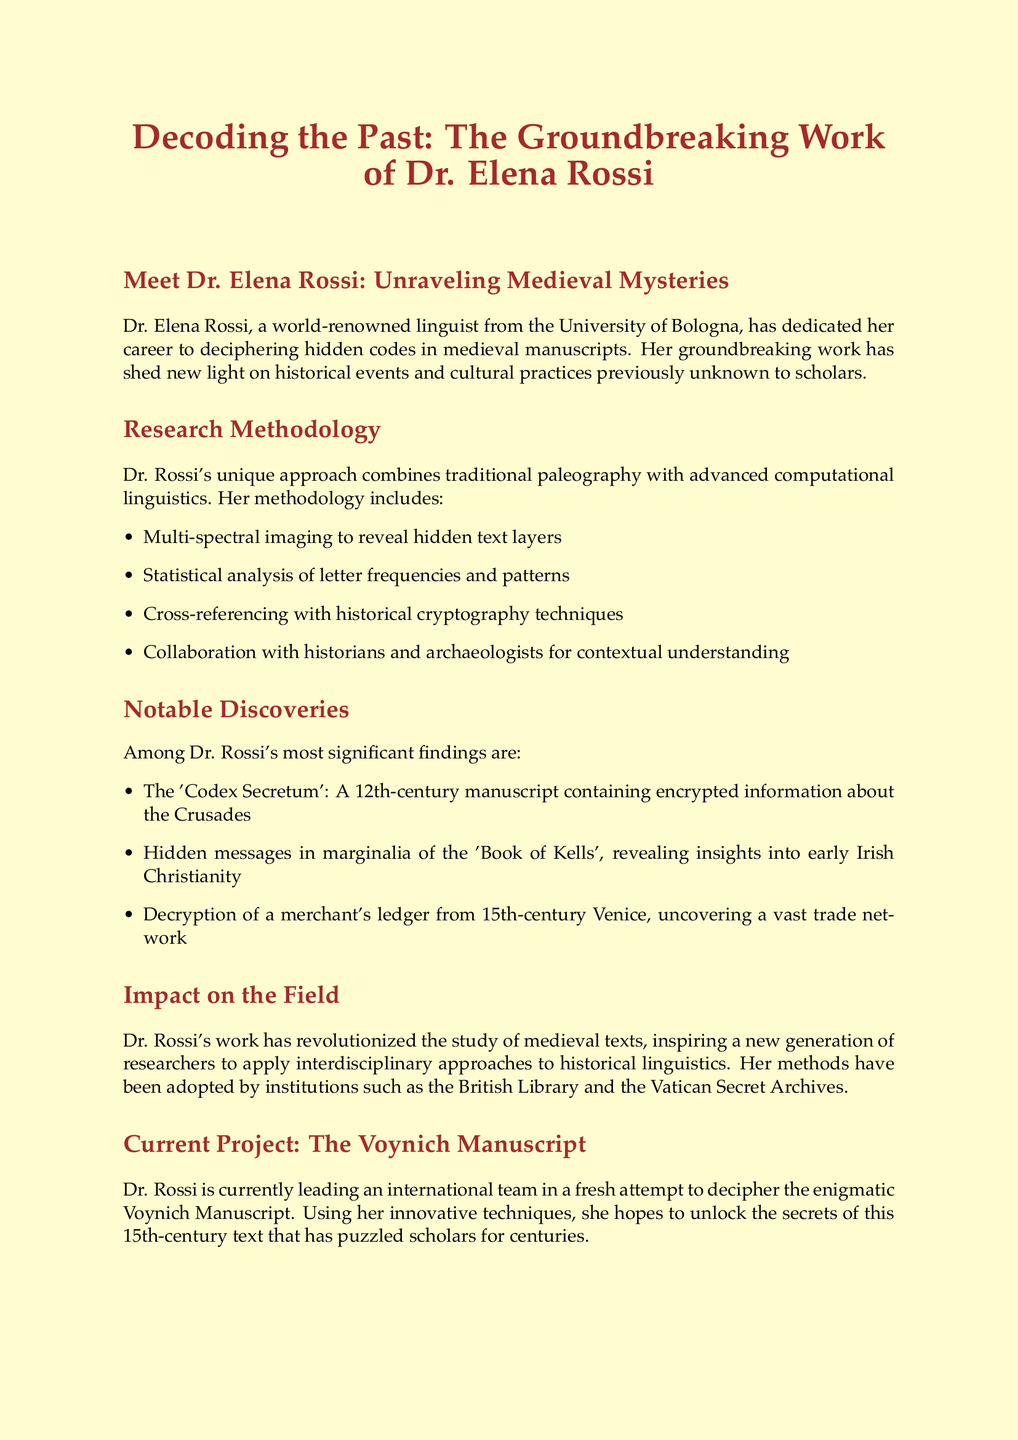What is the title of the newsletter? The title is presented at the beginning of the document, emphasizing the focus on Dr. Elena Rossi's work.
Answer: Decoding the Past: The Groundbreaking Work of Dr. Elena Rossi Who is Dr. Rossi affiliated with? Her affiliation is mentioned in the introductory section of the newsletter, indicating her academic base.
Answer: University of Bologna What innovative technique does Dr. Rossi use to reveal hidden text layers? This technique is listed in the research methodology section, showcasing a significant aspect of her approach.
Answer: Multi-spectral imaging What significant manuscript contains encrypted information about the Crusades? This discovery is acknowledged in the notable discoveries section, highlighting one of her important findings.
Answer: Codex Secretum How many notable discoveries are listed in the document? The number of discoveries is found by counting the specific points mentioned in the notable discoveries section.
Answer: Three Which manuscript is Dr. Rossi currently working on? The current project section indicates the focus of her ongoing research efforts.
Answer: Voynich Manuscript When is Dr. Rossi's upcoming workshop scheduled? The date is indicated in the workshop section, relevant for those interested in her methods.
Answer: September What type of event will Dr. Rossi conduct in Edinburgh? The nature of the event is specified in the workshop section, detailing her contribution to the conference.
Answer: Workshop Who compiled the newsletter? The author of the newsletter is mentioned at the end, highlighting their relationship with Dr. Rossi.
Answer: Dr. Marcus Thorne 